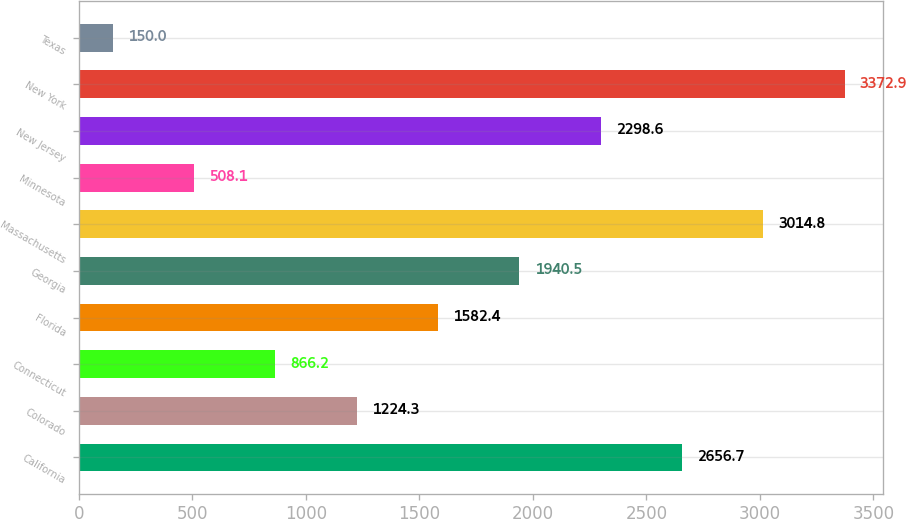Convert chart to OTSL. <chart><loc_0><loc_0><loc_500><loc_500><bar_chart><fcel>California<fcel>Colorado<fcel>Connecticut<fcel>Florida<fcel>Georgia<fcel>Massachusetts<fcel>Minnesota<fcel>New Jersey<fcel>New York<fcel>Texas<nl><fcel>2656.7<fcel>1224.3<fcel>866.2<fcel>1582.4<fcel>1940.5<fcel>3014.8<fcel>508.1<fcel>2298.6<fcel>3372.9<fcel>150<nl></chart> 